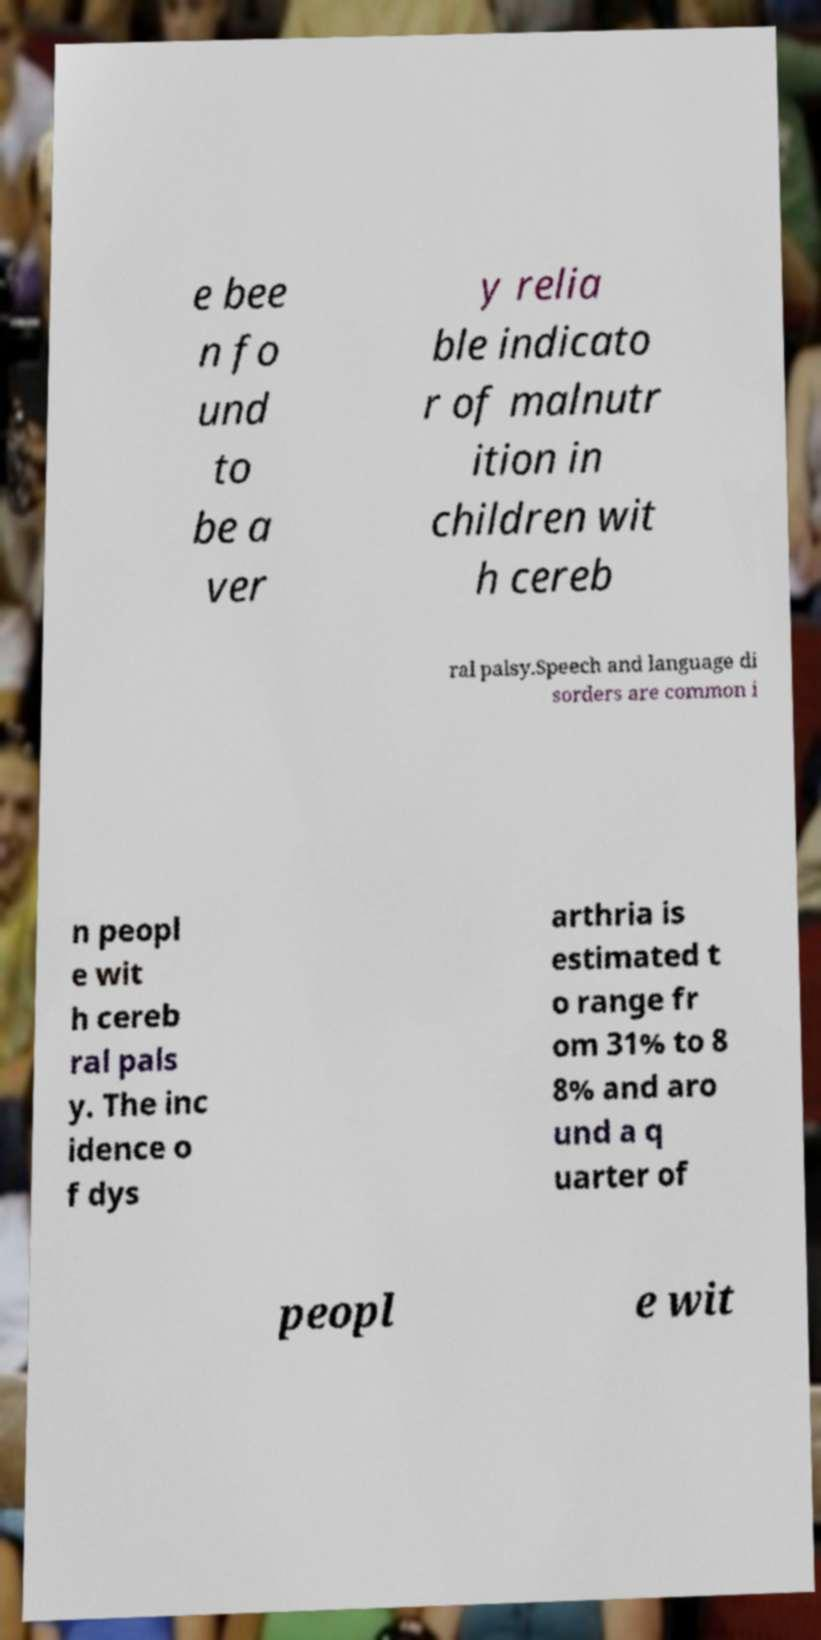I need the written content from this picture converted into text. Can you do that? e bee n fo und to be a ver y relia ble indicato r of malnutr ition in children wit h cereb ral palsy.Speech and language di sorders are common i n peopl e wit h cereb ral pals y. The inc idence o f dys arthria is estimated t o range fr om 31% to 8 8% and aro und a q uarter of peopl e wit 